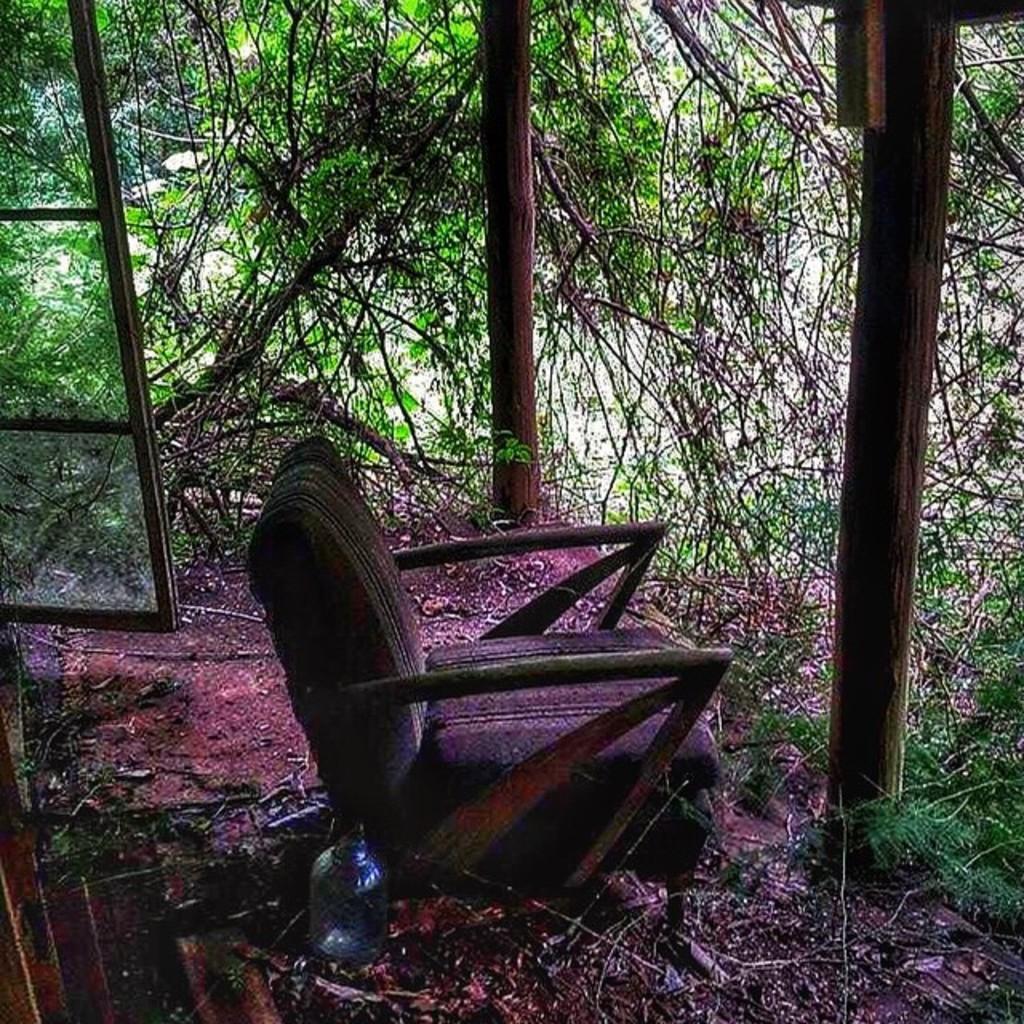Describe this image in one or two sentences. In this image I can see trees and I can see a glass window on the left side, In the middle I can see chair kept on the floor and I can see there are bottles kept back side of the chair. And I can see two beams visible on the right side. 